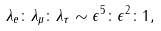<formula> <loc_0><loc_0><loc_500><loc_500>\lambda _ { e } \colon \lambda _ { \mu } \colon \lambda _ { \tau } \sim \epsilon ^ { 5 } \colon \epsilon ^ { 2 } \colon 1 ,</formula> 